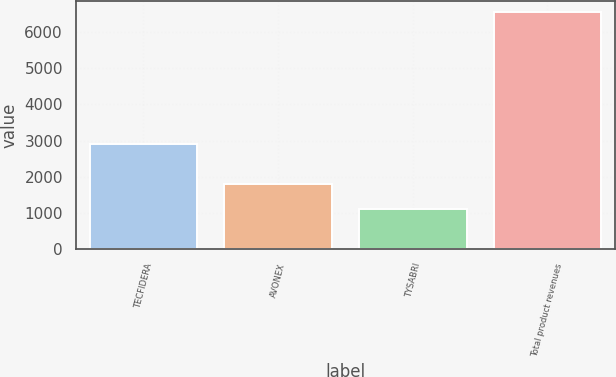Convert chart to OTSL. <chart><loc_0><loc_0><loc_500><loc_500><bar_chart><fcel>TECFIDERA<fcel>AVONEX<fcel>TYSABRI<fcel>Total product revenues<nl><fcel>2908.2<fcel>1790.2<fcel>1103.1<fcel>6545.8<nl></chart> 